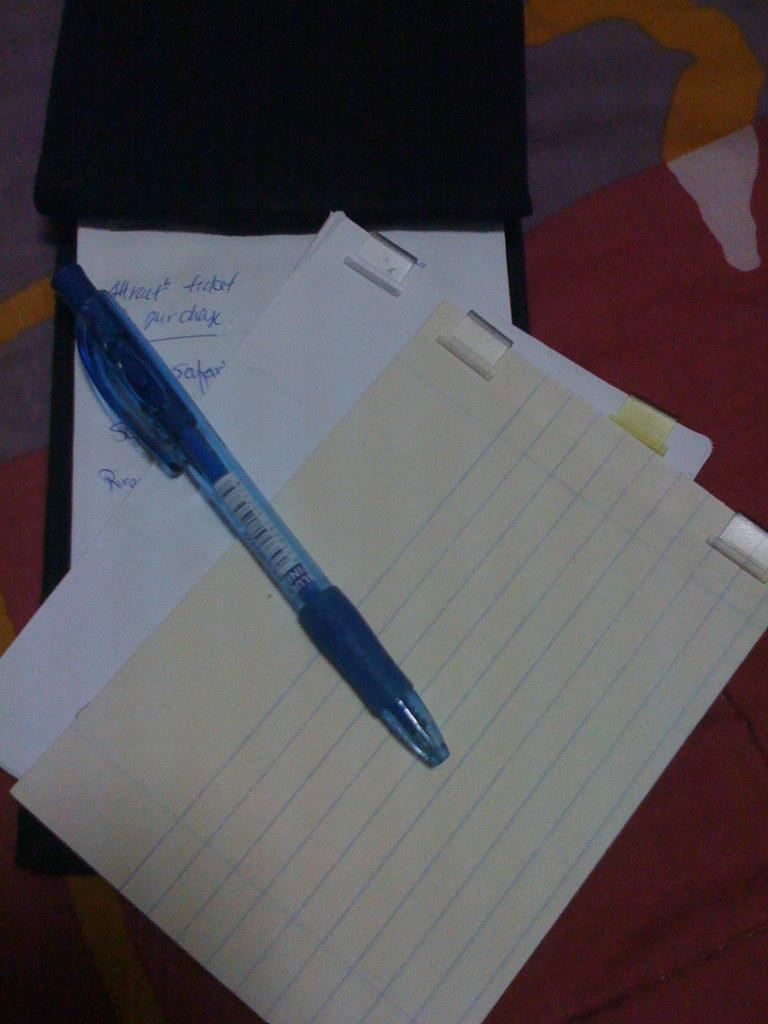What stationery item can be seen in the image? There is a pen in the image. What are the papers used for in the image? The papers have text on them, suggesting they are being used for writing or documentation. Can you describe the object towards the top of the image? Unfortunately, the facts provided do not give enough information to describe the object towards the top of the image. What can be seen in the background of the image? There is a cloth visible in the background of the image. What type of marble is used to write on the papers? There is no marble present in the image. The image only features a pen, papers with text, an unidentified object towards the top, and a cloth visible in the background. 